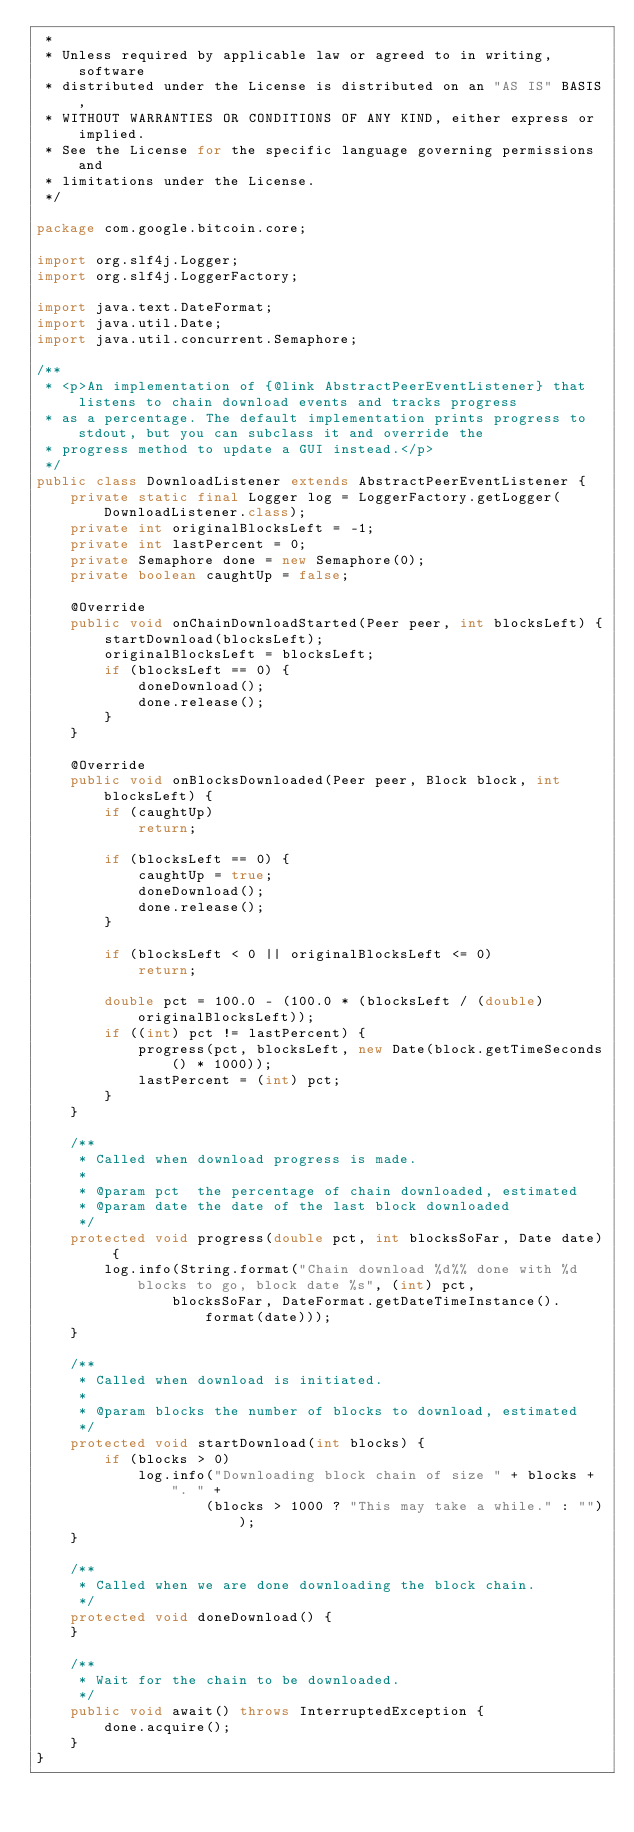<code> <loc_0><loc_0><loc_500><loc_500><_Java_> *
 * Unless required by applicable law or agreed to in writing, software
 * distributed under the License is distributed on an "AS IS" BASIS,
 * WITHOUT WARRANTIES OR CONDITIONS OF ANY KIND, either express or implied.
 * See the License for the specific language governing permissions and
 * limitations under the License.
 */

package com.google.bitcoin.core;

import org.slf4j.Logger;
import org.slf4j.LoggerFactory;

import java.text.DateFormat;
import java.util.Date;
import java.util.concurrent.Semaphore;

/**
 * <p>An implementation of {@link AbstractPeerEventListener} that listens to chain download events and tracks progress
 * as a percentage. The default implementation prints progress to stdout, but you can subclass it and override the
 * progress method to update a GUI instead.</p>
 */
public class DownloadListener extends AbstractPeerEventListener {
    private static final Logger log = LoggerFactory.getLogger(DownloadListener.class);
    private int originalBlocksLeft = -1;
    private int lastPercent = 0;
    private Semaphore done = new Semaphore(0);
    private boolean caughtUp = false;

    @Override
    public void onChainDownloadStarted(Peer peer, int blocksLeft) {
        startDownload(blocksLeft);
        originalBlocksLeft = blocksLeft;
        if (blocksLeft == 0) {
            doneDownload();
            done.release();
        }
    }

    @Override
    public void onBlocksDownloaded(Peer peer, Block block, int blocksLeft) {
        if (caughtUp)
            return;

        if (blocksLeft == 0) {
            caughtUp = true;
            doneDownload();
            done.release();
        }

        if (blocksLeft < 0 || originalBlocksLeft <= 0)
            return;

        double pct = 100.0 - (100.0 * (blocksLeft / (double) originalBlocksLeft));
        if ((int) pct != lastPercent) {
            progress(pct, blocksLeft, new Date(block.getTimeSeconds() * 1000));
            lastPercent = (int) pct;
        }
    }

    /**
     * Called when download progress is made.
     *
     * @param pct  the percentage of chain downloaded, estimated
     * @param date the date of the last block downloaded
     */
    protected void progress(double pct, int blocksSoFar, Date date) {
        log.info(String.format("Chain download %d%% done with %d blocks to go, block date %s", (int) pct,
                blocksSoFar, DateFormat.getDateTimeInstance().format(date)));
    }

    /**
     * Called when download is initiated.
     *
     * @param blocks the number of blocks to download, estimated
     */
    protected void startDownload(int blocks) {
        if (blocks > 0)
            log.info("Downloading block chain of size " + blocks + ". " +
                    (blocks > 1000 ? "This may take a while." : ""));
    }

    /**
     * Called when we are done downloading the block chain.
     */
    protected void doneDownload() {
    }

    /**
     * Wait for the chain to be downloaded.
     */
    public void await() throws InterruptedException {
        done.acquire();
    }
}
</code> 